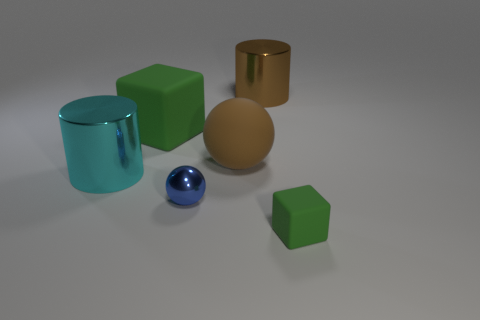Add 1 big brown metal cylinders. How many objects exist? 7 Subtract all balls. How many objects are left? 4 Subtract all big brown rubber objects. Subtract all big matte blocks. How many objects are left? 4 Add 1 cyan objects. How many cyan objects are left? 2 Add 5 tiny blocks. How many tiny blocks exist? 6 Subtract 0 gray cubes. How many objects are left? 6 